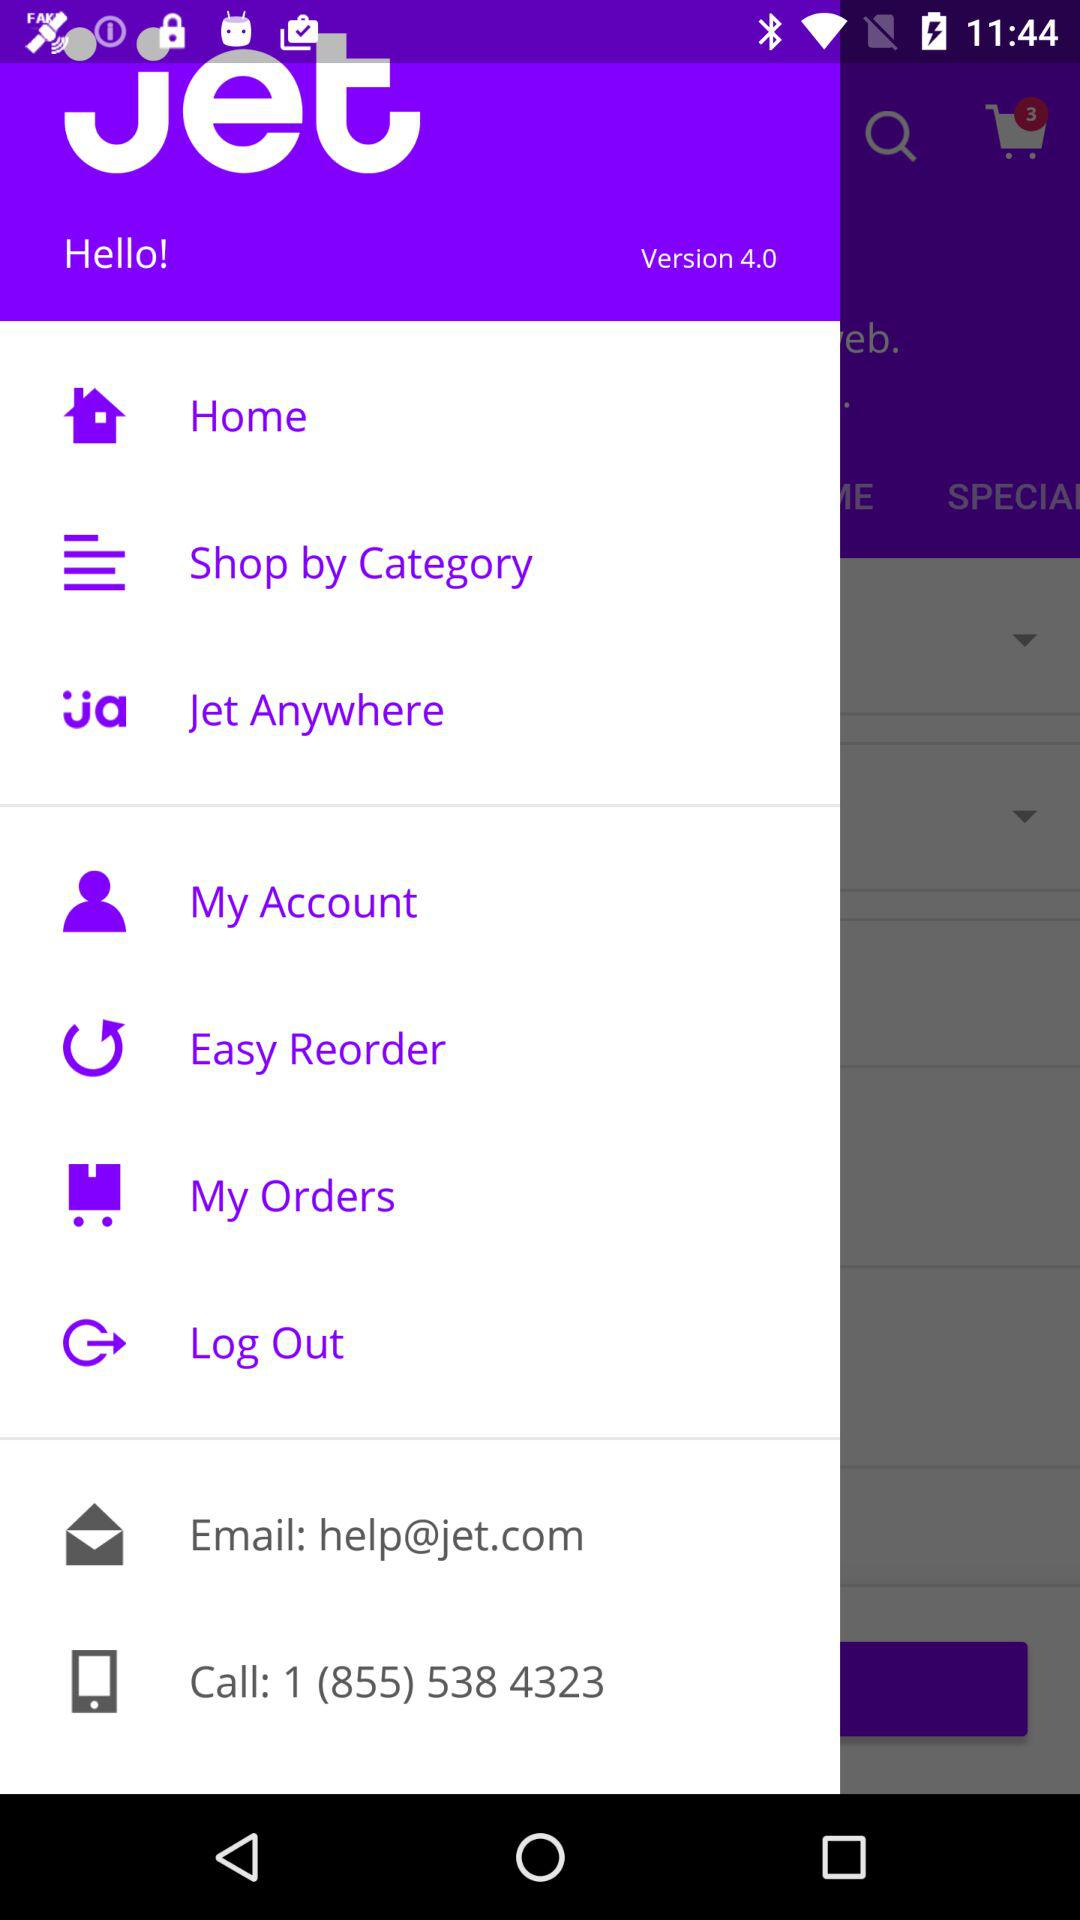What version is shown? The version is 4.0. 